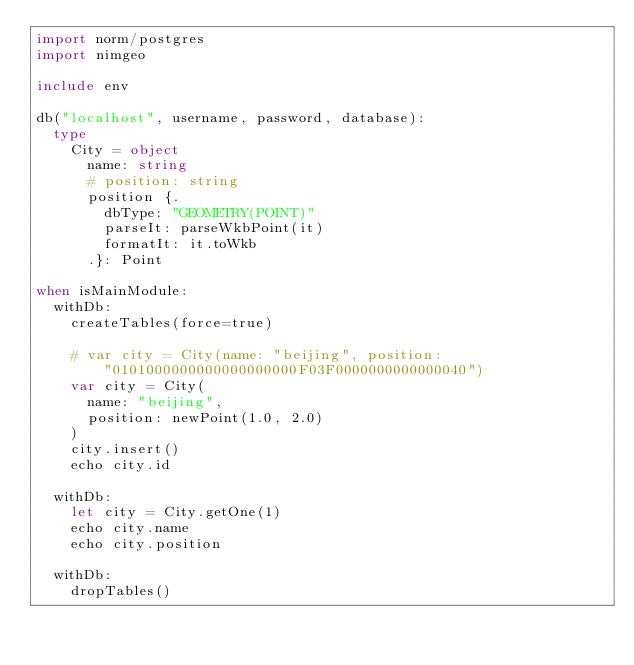Convert code to text. <code><loc_0><loc_0><loc_500><loc_500><_Nim_>import norm/postgres
import nimgeo

include env

db("localhost", username, password, database):
  type
    City = object
      name: string
      # position: string
      position {.
        dbType: "GEOMETRY(POINT)"
        parseIt: parseWkbPoint(it)
        formatIt: it.toWkb
      .}: Point

when isMainModule:
  withDb:
    createTables(force=true)

    # var city = City(name: "beijing", position: "0101000000000000000000F03F0000000000000040")
    var city = City(
      name: "beijing",
      position: newPoint(1.0, 2.0)
    )
    city.insert()
    echo city.id
  
  withDb:
    let city = City.getOne(1)
    echo city.name
    echo city.position

  withDb:
    dropTables()</code> 